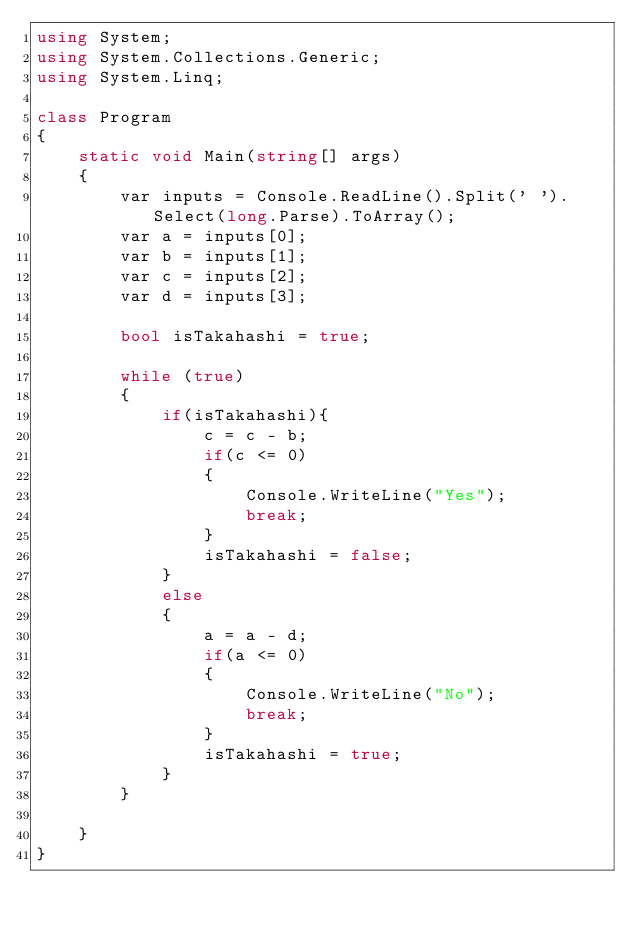Convert code to text. <code><loc_0><loc_0><loc_500><loc_500><_C#_>using System;
using System.Collections.Generic;
using System.Linq;

class Program
{
    static void Main(string[] args)
    {
        var inputs = Console.ReadLine().Split(' ').Select(long.Parse).ToArray();
        var a = inputs[0];
        var b = inputs[1];
        var c = inputs[2];
        var d = inputs[3];

        bool isTakahashi = true;

        while (true)
        {
            if(isTakahashi){
                c = c - b;
                if(c <= 0)
                {
                    Console.WriteLine("Yes");
                    break;
                }
                isTakahashi = false;
            }
            else
            {
                a = a - d;
                if(a <= 0)
                {
                    Console.WriteLine("No");
                    break;
                }
                isTakahashi = true;
            }
        }

    }
}</code> 